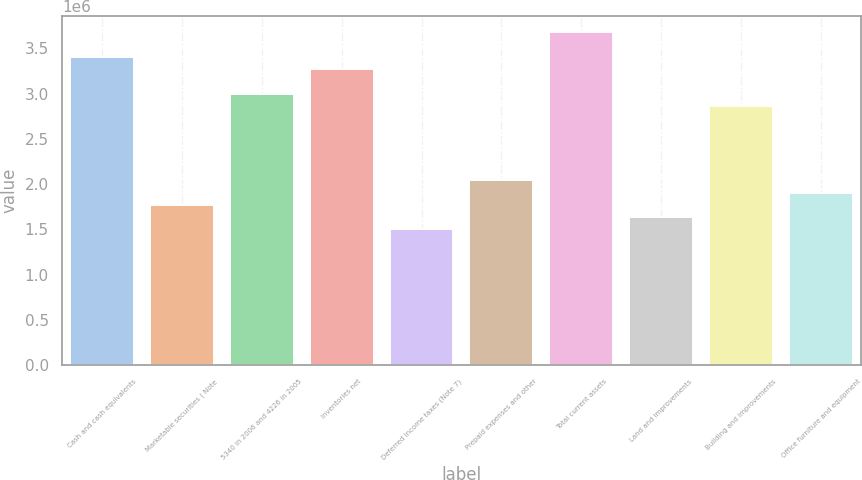<chart> <loc_0><loc_0><loc_500><loc_500><bar_chart><fcel>Cash and cash equivalents<fcel>Marketable securities ( Note<fcel>5340 in 2006 and 4226 in 2005<fcel>Inventories net<fcel>Deferred income taxes (Note 7)<fcel>Prepaid expenses and other<fcel>Total current assets<fcel>Land and improvements<fcel>Building and improvements<fcel>Office furniture and equipment<nl><fcel>3.40397e+06<fcel>1.77058e+06<fcel>2.99562e+06<fcel>3.26785e+06<fcel>1.49835e+06<fcel>2.04281e+06<fcel>3.6762e+06<fcel>1.63447e+06<fcel>2.8595e+06<fcel>1.9067e+06<nl></chart> 